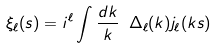Convert formula to latex. <formula><loc_0><loc_0><loc_500><loc_500>\xi _ { \ell } ( s ) = i ^ { \ell } \int \frac { d k } { k } \ \Delta _ { \ell } ( k ) j _ { \ell } ( k s )</formula> 